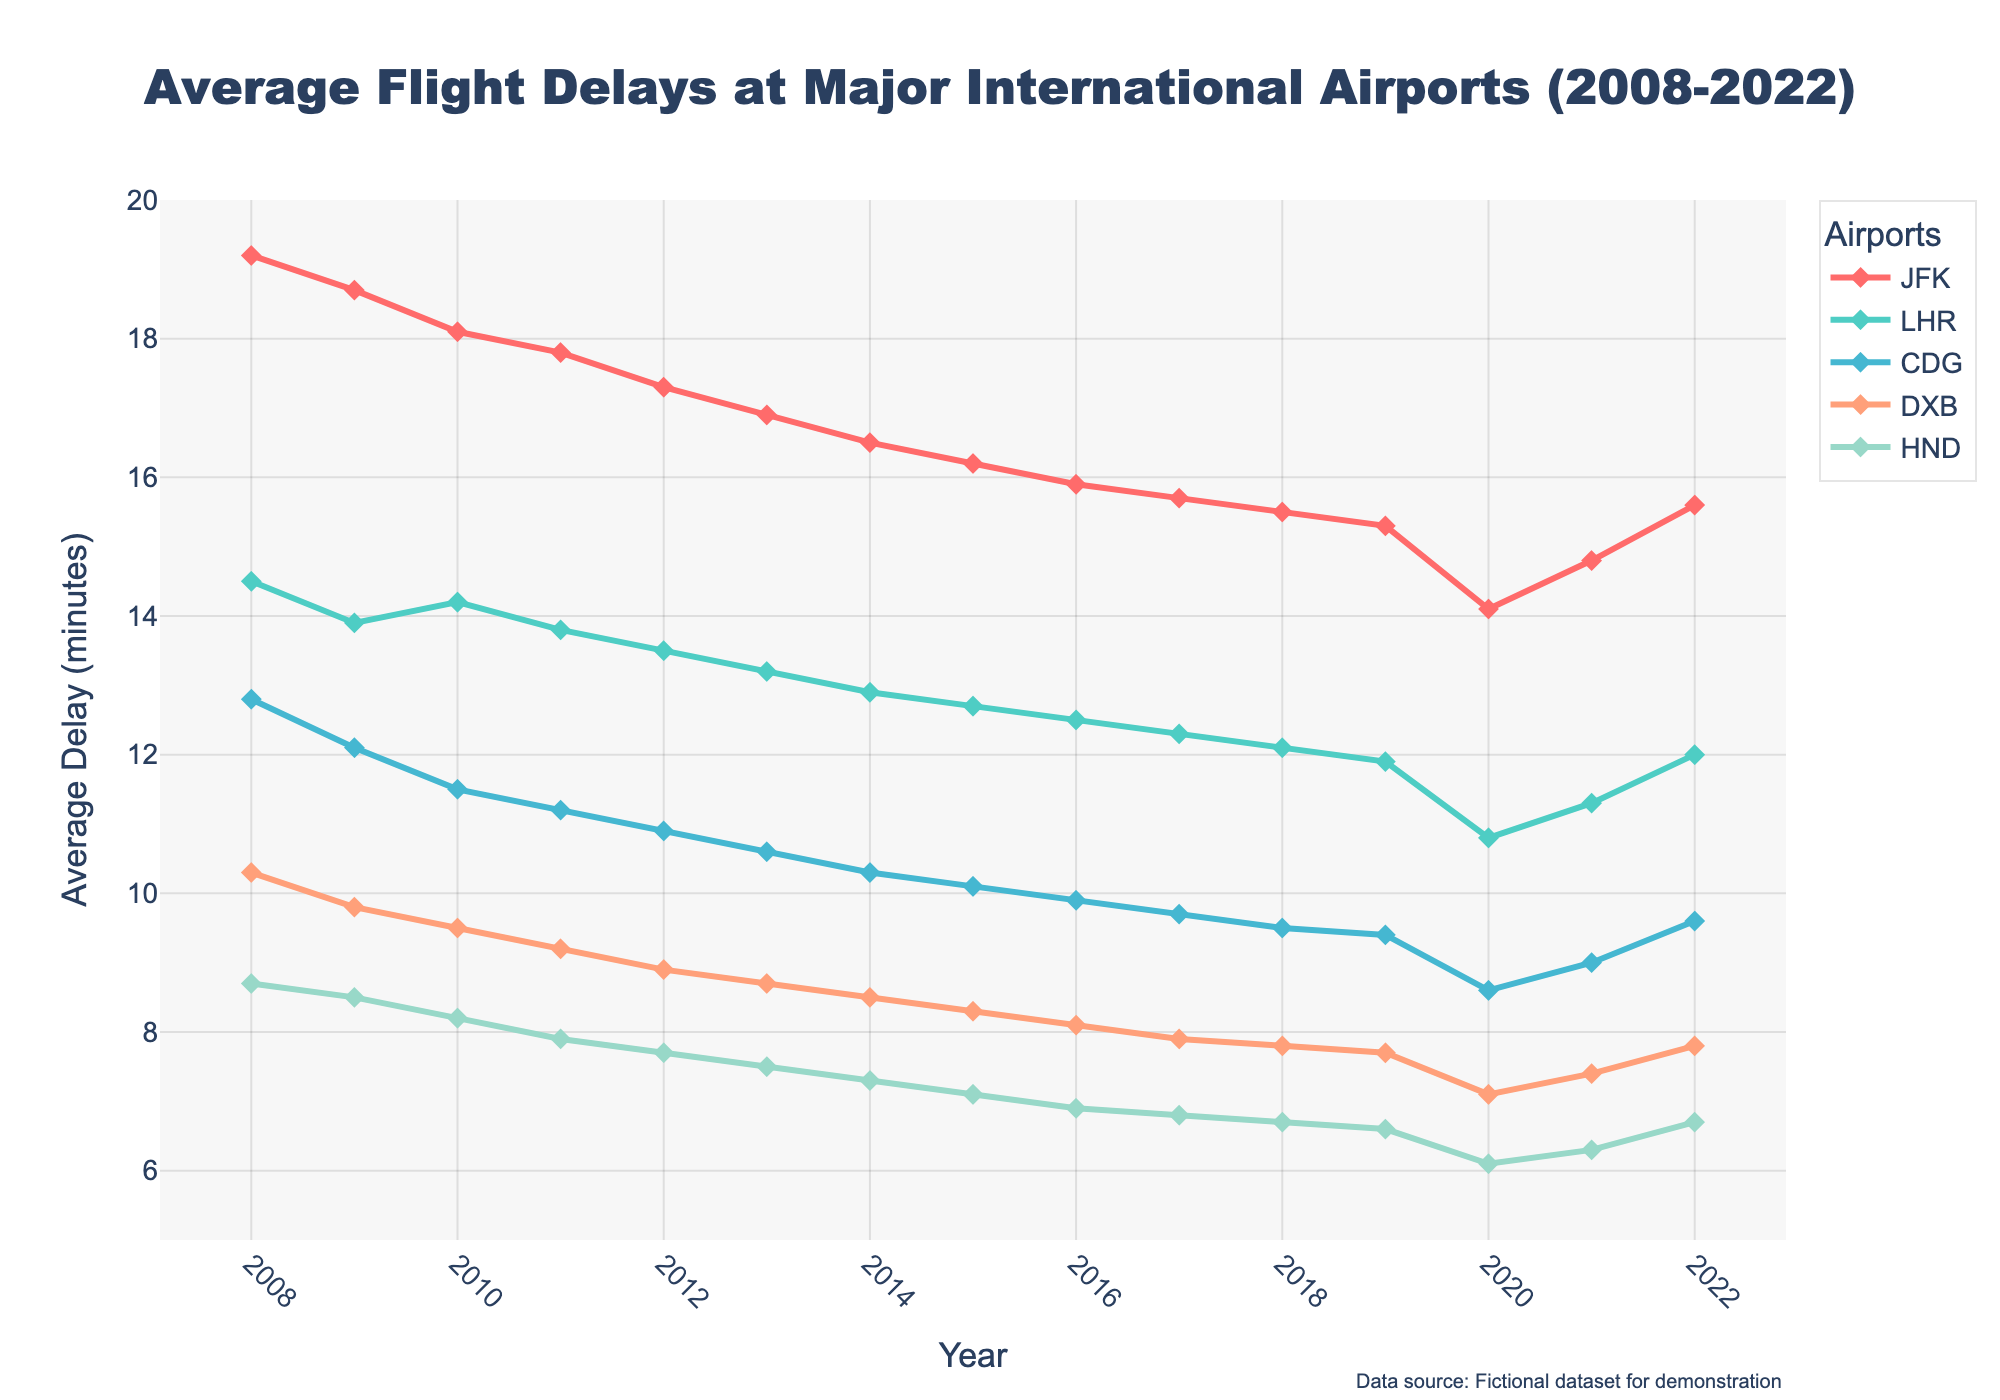Which airport had the highest average delay in 2010? In the figure, locate the data point for the year 2010. Observe the different lines representing each airport. Identify the line with the highest value for that year.
Answer: JFK What is the overall trend in average delays for DXB from 2008 to 2022? Follow the line representing DXB from 2008 to 2022. Notice the general direction of the line as it moves downward over the years, indicating a decrease in average delays.
Answer: Decreasing Which year experienced the lowest average delay at HND? Trace the line for HND across the years and identify the minimum value on the y-axis. Check the corresponding year on the x-axis where this minimum occurs.
Answer: 2020 Between 2015 and 2020, which airport had the most consistent average delay? Compare the fluctuations in the average delays for each airport's lines between 2015 and 2020. Determine which line remains relatively flat and stable indicating consistent average delays.
Answer: HND By how much did the average delay at JFK decrease from 2008 to 2019? Locate the data points for JFK in the years 2008 and 2019. Subtract the delay in 2019 from the delay in 2008 to find the decrease. Calculation: 19.2 - 15.3 = 3.9.
Answer: 3.9 minutes Which airport had the most spikes in average delays during the period? Look at the lines representing each airport and analyze the jaggedness or the number of peaks and troughs within each line over the years. Determine which one has the most noticeable spikes.
Answer: JFK If the average delay trend continues, which airport is likely to have the lowest delay in the next 5 years? Observe the slopes of the lines over the most recent years (2020-2022) and determine which airport’s line shows the most significant downward trend.
Answer: HND Which airport had the sharpest increase in average delay during any single year in the dataset? Examine the lines for each airport and identify the year with the steepest upward slope. This indicates the sharpest increase in delays from one year to the next.
Answer: JFK (2021) What is the average delay for LHR over the entire period? Sum the values of average delays for LHR from 2008 to 2022 and divide by the number of years (15 years). Calculation: (14.5 + 13.9 + 14.2 + 13.8 + 13.5 + 13.2 + 12.9 + 12.7 + 12.5 + 12.3 + 12.1 + 11.9 + 10.8 + 11.3 + 12.0) / 15 = 12.9.
Answer: 12.9 minutes 